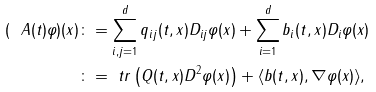<formula> <loc_0><loc_0><loc_500><loc_500>( \ A ( t ) \varphi ) ( x ) & \colon = \sum _ { i , j = 1 } ^ { d } q _ { i j } ( t , x ) D _ { i j } \varphi ( x ) + \sum _ { i = 1 } ^ { d } b _ { i } ( t , x ) D _ { i } \varphi ( x ) \\ & \colon = \ t r \left ( Q ( t , x ) D ^ { 2 } \varphi ( x ) \right ) + \langle b ( t , x ) , \nabla \varphi ( x ) \rangle ,</formula> 